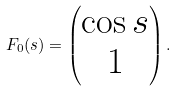Convert formula to latex. <formula><loc_0><loc_0><loc_500><loc_500>F _ { 0 } ( s ) = \left ( \begin{matrix} \cos s \\ 1 \end{matrix} \right ) .</formula> 